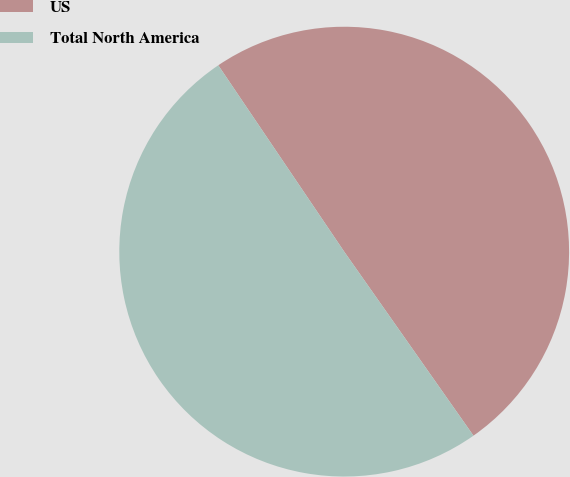Convert chart. <chart><loc_0><loc_0><loc_500><loc_500><pie_chart><fcel>US<fcel>Total North America<nl><fcel>49.71%<fcel>50.29%<nl></chart> 